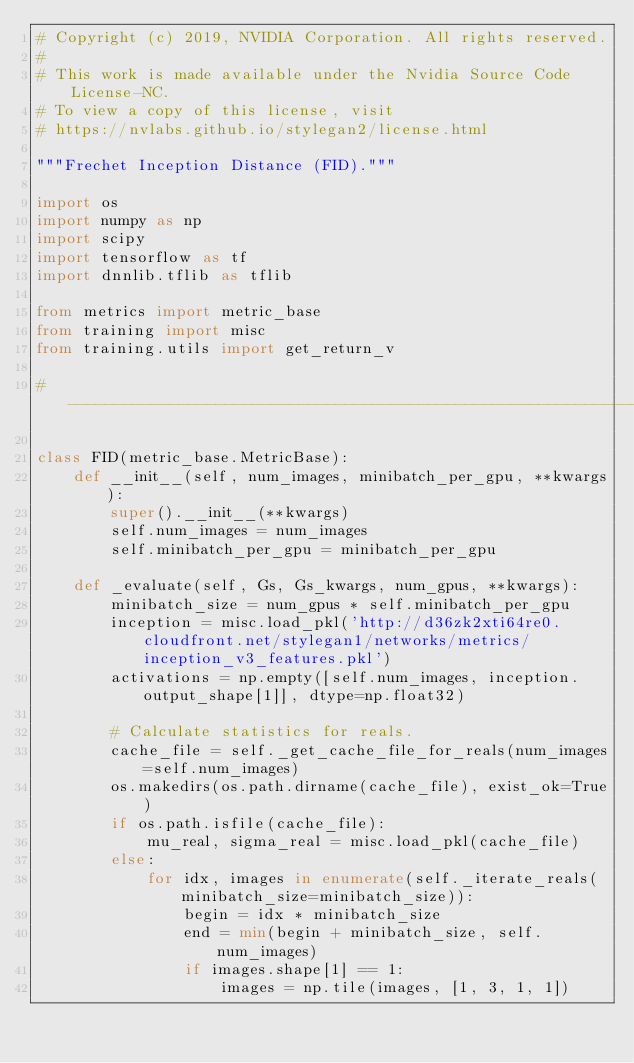Convert code to text. <code><loc_0><loc_0><loc_500><loc_500><_Python_># Copyright (c) 2019, NVIDIA Corporation. All rights reserved.
#
# This work is made available under the Nvidia Source Code License-NC.
# To view a copy of this license, visit
# https://nvlabs.github.io/stylegan2/license.html

"""Frechet Inception Distance (FID)."""

import os
import numpy as np
import scipy
import tensorflow as tf
import dnnlib.tflib as tflib

from metrics import metric_base
from training import misc
from training.utils import get_return_v

#----------------------------------------------------------------------------

class FID(metric_base.MetricBase):
    def __init__(self, num_images, minibatch_per_gpu, **kwargs):
        super().__init__(**kwargs)
        self.num_images = num_images
        self.minibatch_per_gpu = minibatch_per_gpu

    def _evaluate(self, Gs, Gs_kwargs, num_gpus, **kwargs):
        minibatch_size = num_gpus * self.minibatch_per_gpu
        inception = misc.load_pkl('http://d36zk2xti64re0.cloudfront.net/stylegan1/networks/metrics/inception_v3_features.pkl')
        activations = np.empty([self.num_images, inception.output_shape[1]], dtype=np.float32)

        # Calculate statistics for reals.
        cache_file = self._get_cache_file_for_reals(num_images=self.num_images)
        os.makedirs(os.path.dirname(cache_file), exist_ok=True)
        if os.path.isfile(cache_file):
            mu_real, sigma_real = misc.load_pkl(cache_file)
        else:
            for idx, images in enumerate(self._iterate_reals(minibatch_size=minibatch_size)):
                begin = idx * minibatch_size
                end = min(begin + minibatch_size, self.num_images)
                if images.shape[1] == 1:
                    images = np.tile(images, [1, 3, 1, 1])</code> 